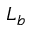Convert formula to latex. <formula><loc_0><loc_0><loc_500><loc_500>L _ { b }</formula> 